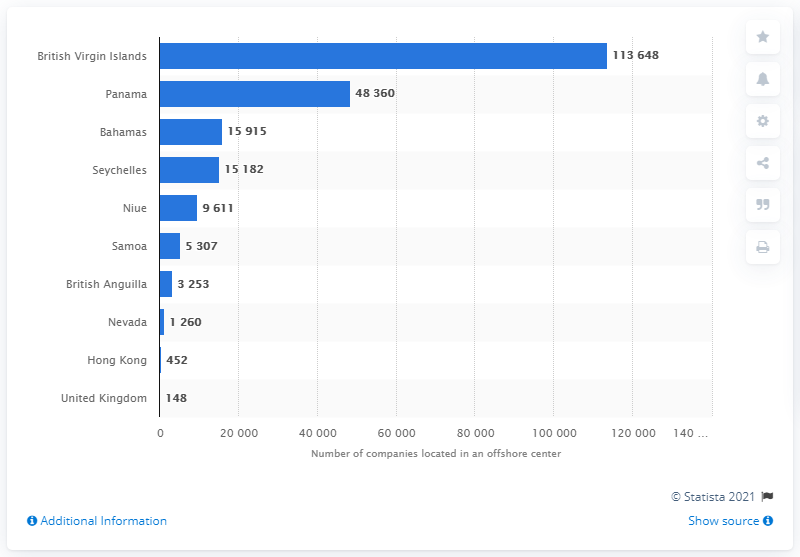Outline some significant characteristics in this image. Mossack Fonseca is headquartered in Panama. 